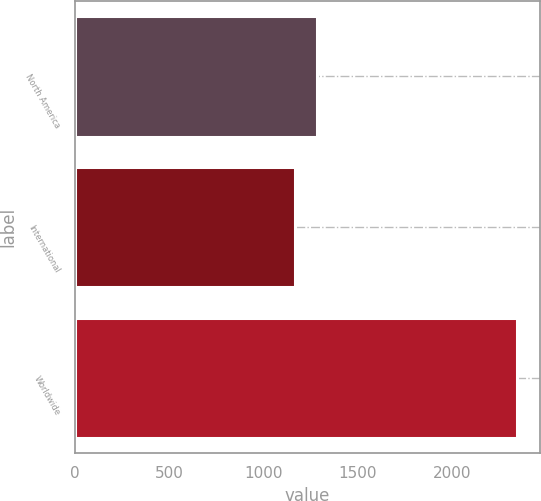Convert chart to OTSL. <chart><loc_0><loc_0><loc_500><loc_500><bar_chart><fcel>North America<fcel>International<fcel>Worldwide<nl><fcel>1285.8<fcel>1168<fcel>2346<nl></chart> 